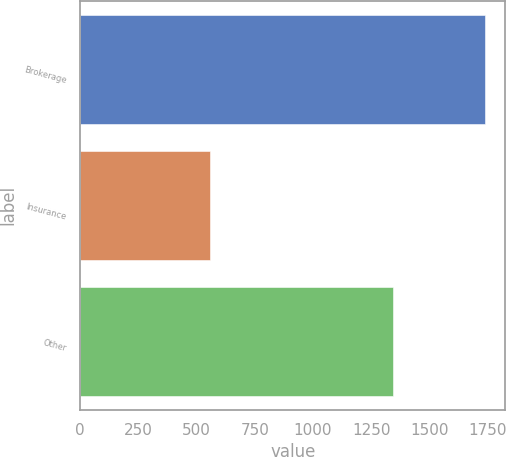Convert chart to OTSL. <chart><loc_0><loc_0><loc_500><loc_500><bar_chart><fcel>Brokerage<fcel>Insurance<fcel>Other<nl><fcel>1740<fcel>557<fcel>1345<nl></chart> 